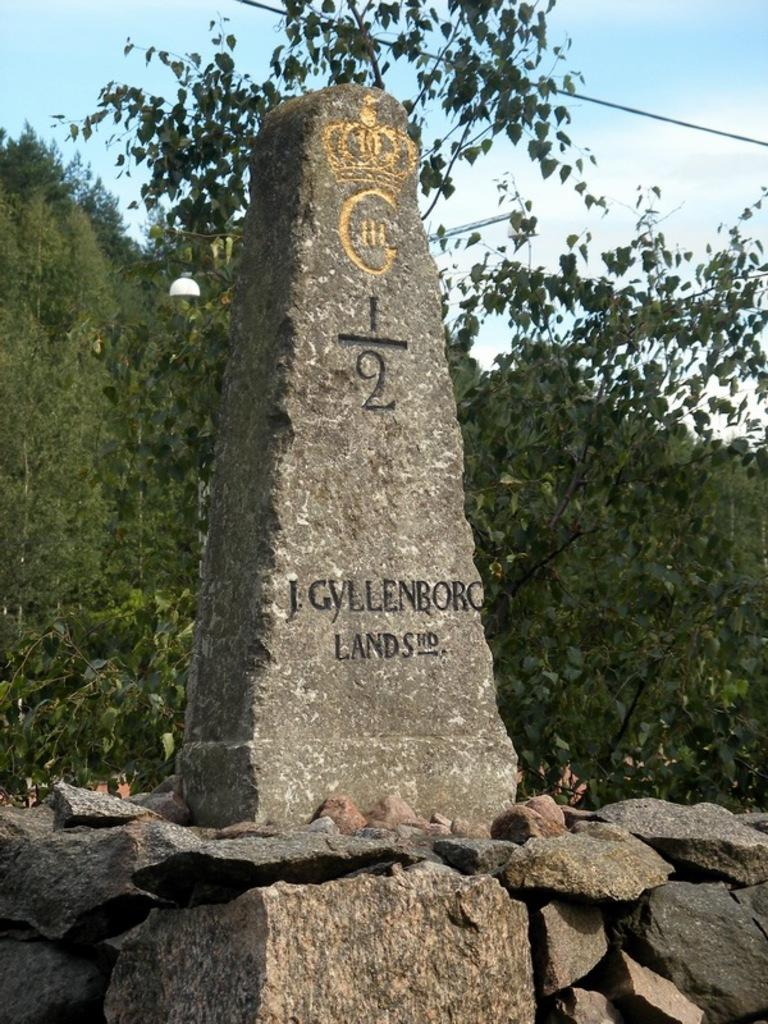What is the main object in the image? There is a stone in the image. What is written or depicted on the stone? There is text on the stone. What else can be seen at the bottom of the image? There are many stones at the bottom of the image. What is visible at the top of the image? The sky is visible at the top of the image. Can you see a skate flying through the sky in the image? No, there is no skate present in the image, and the sky is clear. 